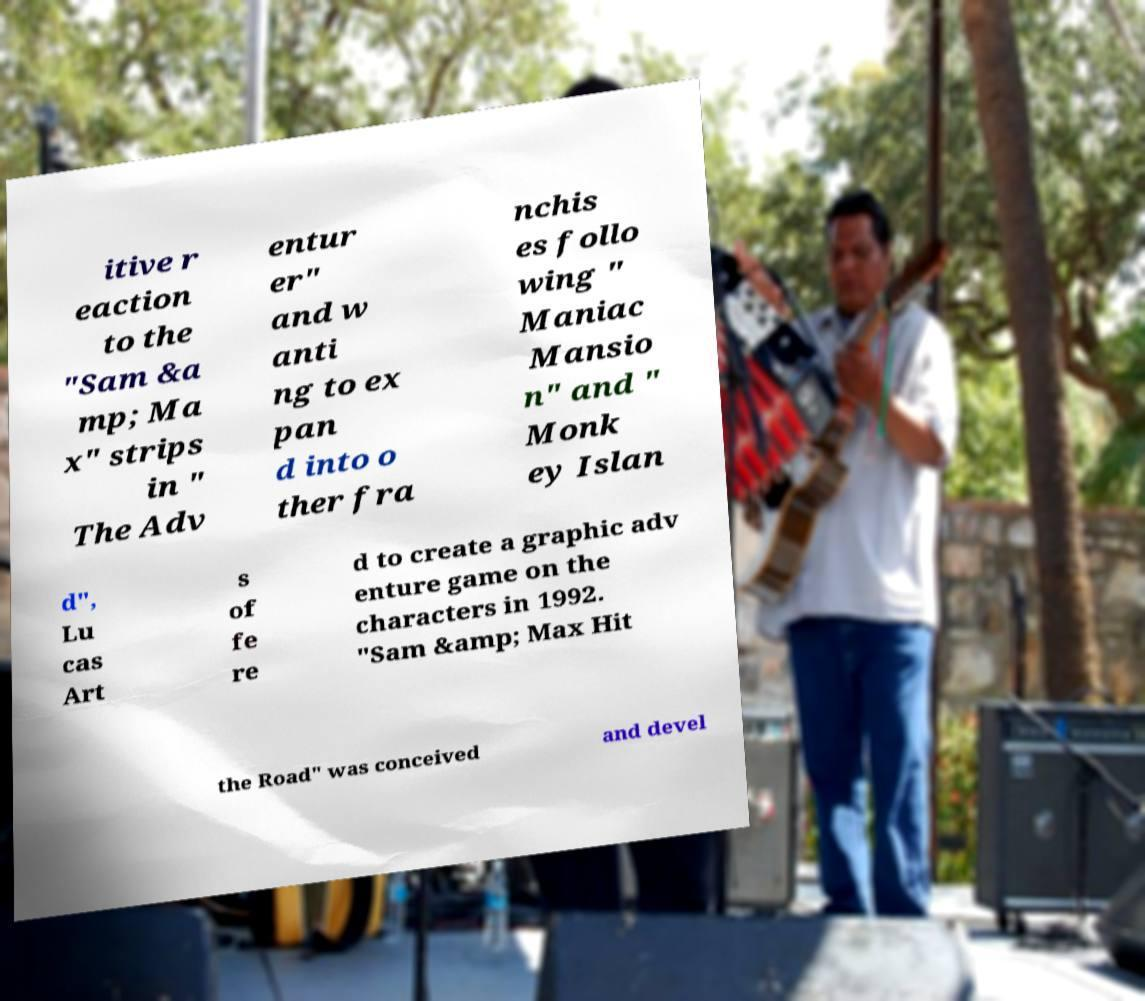Can you accurately transcribe the text from the provided image for me? itive r eaction to the "Sam &a mp; Ma x" strips in " The Adv entur er" and w anti ng to ex pan d into o ther fra nchis es follo wing " Maniac Mansio n" and " Monk ey Islan d", Lu cas Art s of fe re d to create a graphic adv enture game on the characters in 1992. "Sam &amp; Max Hit the Road" was conceived and devel 